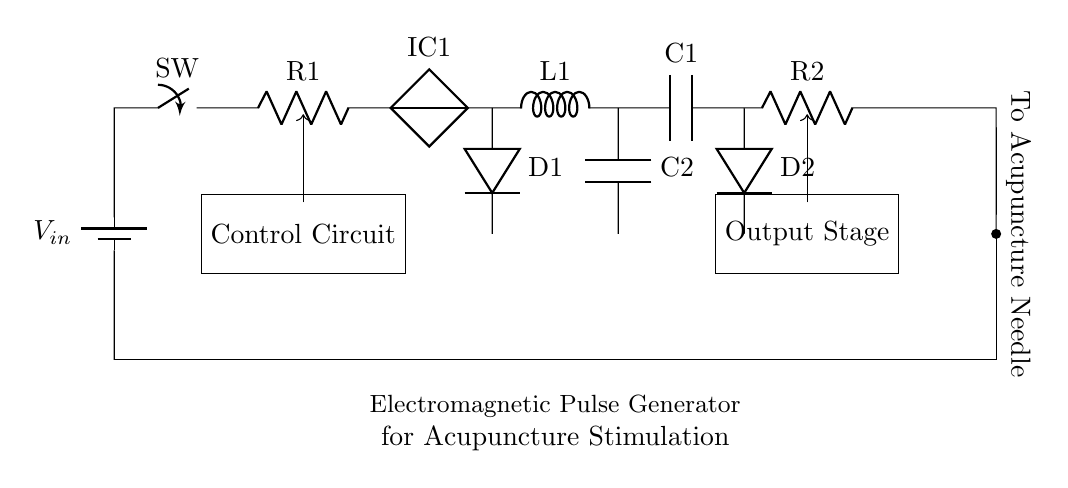What is the input voltage of this circuit? The input voltage is indicated as \( V_{in} \) at the top left, which represents the source voltage for the circuit.
Answer: \( V_{in} \) What components are used in the output stage? The output stage consists of a capacitor labeled \( C1 \), a second diode labeled \( D2 \), and a resistor labeled \( R2 \), all connected in series.
Answer: Capacitor, Diode, Resistor How many diodes are in the circuit? There are two diodes represented by \( D1 \) and \( D2 \) on the circuit diagram.
Answer: 2 What role does the control circuit play? The control circuit directs the flow of current through the various components, influencing the timing and intensity of the electromagnetic pulses generated for stimulation.
Answer: Directs flow What is the purpose of the inductor in this circuit? The inductor labeled \( L1 \) is used to store energy and helps to generate the electromagnetic pulses needed for the acupuncture stimulation process.
Answer: Store energy How does the output connect to the acupuncture needle? The output from the circuit connects to the acupuncture needle via a short segment labeled "To Acupuncture Needle" directing the oscillating current to it.
Answer: Through a short wire 